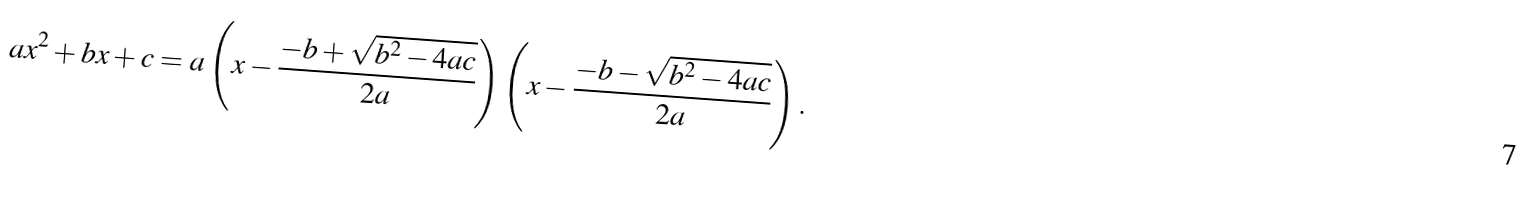<formula> <loc_0><loc_0><loc_500><loc_500>a x ^ { 2 } + b x + c = a \left ( x - { \frac { - b + { \sqrt { b ^ { 2 } - 4 a c } } } { 2 a } } \right ) \left ( x - { \frac { - b - { \sqrt { b ^ { 2 } - 4 a c } } } { 2 a } } \right ) .</formula> 